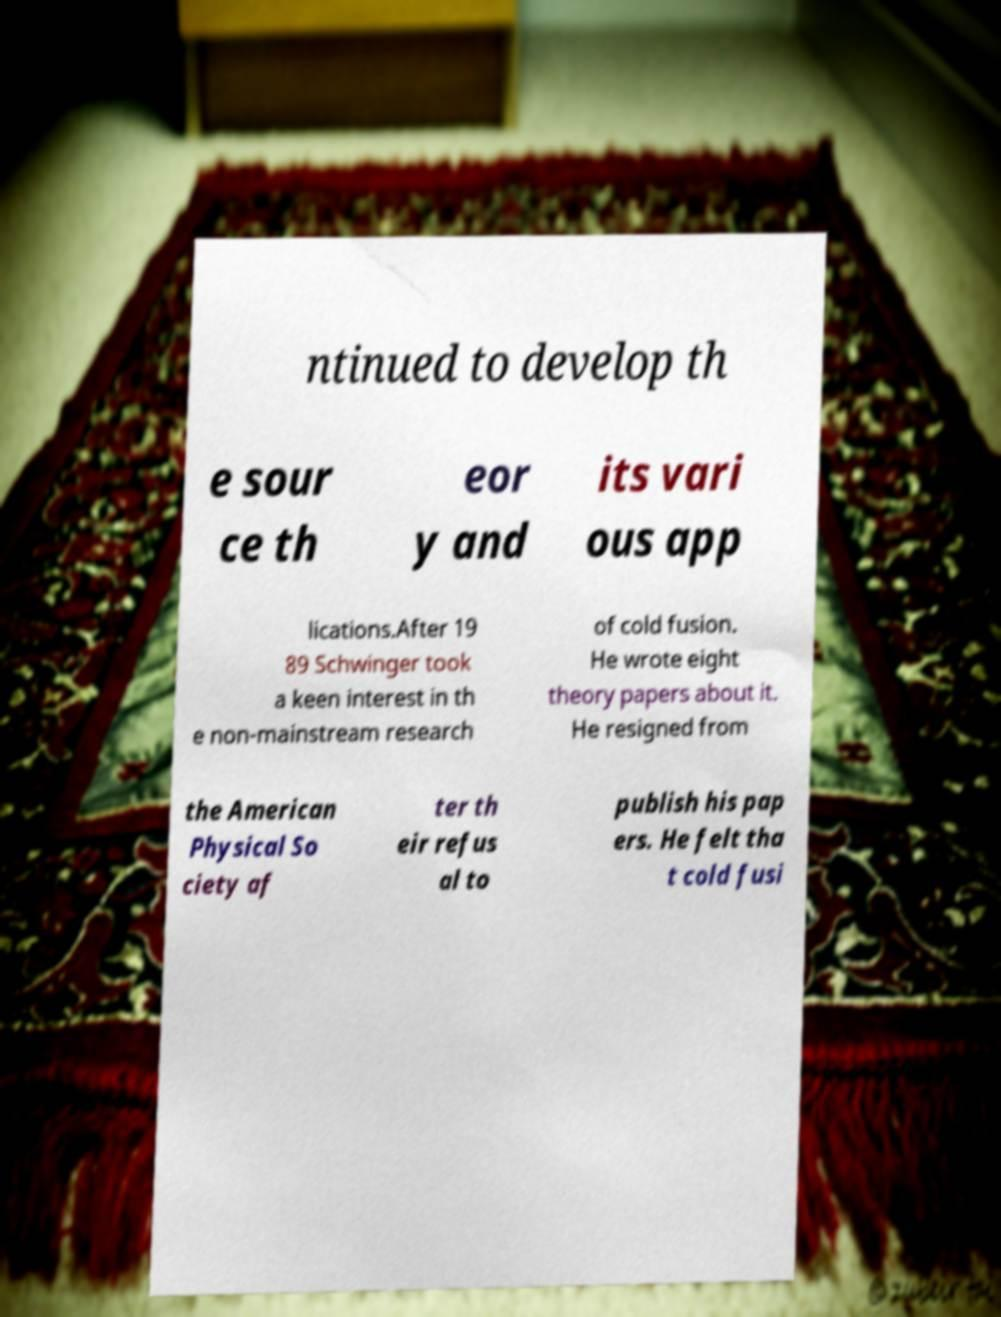For documentation purposes, I need the text within this image transcribed. Could you provide that? ntinued to develop th e sour ce th eor y and its vari ous app lications.After 19 89 Schwinger took a keen interest in th e non-mainstream research of cold fusion. He wrote eight theory papers about it. He resigned from the American Physical So ciety af ter th eir refus al to publish his pap ers. He felt tha t cold fusi 